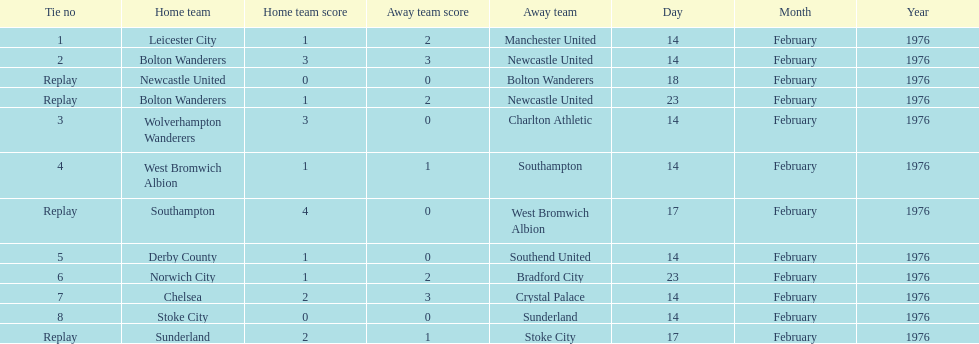Who had a better score, manchester united or wolverhampton wanderers? Wolverhampton Wanderers. Help me parse the entirety of this table. {'header': ['Tie no', 'Home team', 'Home team score', 'Away team score', 'Away team', 'Day', 'Month', 'Year'], 'rows': [['1', 'Leicester City', '1', '2', 'Manchester United', '14', 'February', '1976'], ['2', 'Bolton Wanderers', '3', '3', 'Newcastle United', '14', 'February', '1976'], ['Replay', 'Newcastle United', '0', '0', 'Bolton Wanderers', '18', 'February', '1976'], ['Replay', 'Bolton Wanderers', '1', '2', 'Newcastle United', '23', 'February', '1976'], ['3', 'Wolverhampton Wanderers', '3', '0', 'Charlton Athletic', '14', 'February', '1976'], ['4', 'West Bromwich Albion', '1', '1', 'Southampton', '14', 'February', '1976'], ['Replay', 'Southampton', '4', '0', 'West Bromwich Albion', '17', 'February', '1976'], ['5', 'Derby County', '1', '0', 'Southend United', '14', 'February', '1976'], ['6', 'Norwich City', '1', '2', 'Bradford City', '23', 'February', '1976'], ['7', 'Chelsea', '2', '3', 'Crystal Palace', '14', 'February', '1976'], ['8', 'Stoke City', '0', '0', 'Sunderland', '14', 'February', '1976'], ['Replay', 'Sunderland', '2', '1', 'Stoke City', '17', 'February', '1976']]} 